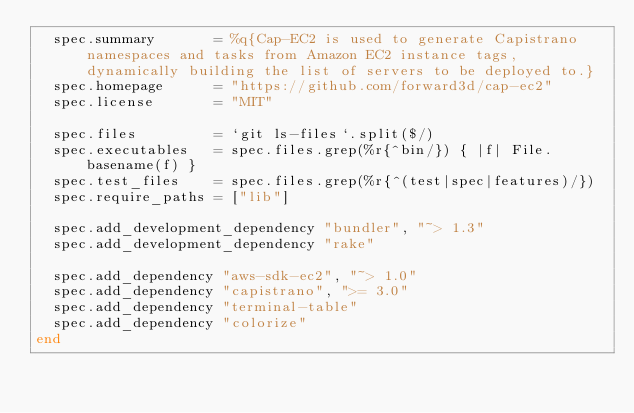<code> <loc_0><loc_0><loc_500><loc_500><_Ruby_>  spec.summary       = %q{Cap-EC2 is used to generate Capistrano namespaces and tasks from Amazon EC2 instance tags, dynamically building the list of servers to be deployed to.}
  spec.homepage      = "https://github.com/forward3d/cap-ec2"
  spec.license       = "MIT"

  spec.files         = `git ls-files`.split($/)
  spec.executables   = spec.files.grep(%r{^bin/}) { |f| File.basename(f) }
  spec.test_files    = spec.files.grep(%r{^(test|spec|features)/})
  spec.require_paths = ["lib"]

  spec.add_development_dependency "bundler", "~> 1.3"
  spec.add_development_dependency "rake"

  spec.add_dependency "aws-sdk-ec2", "~> 1.0"
  spec.add_dependency "capistrano", ">= 3.0"
  spec.add_dependency "terminal-table"
  spec.add_dependency "colorize"
end
</code> 